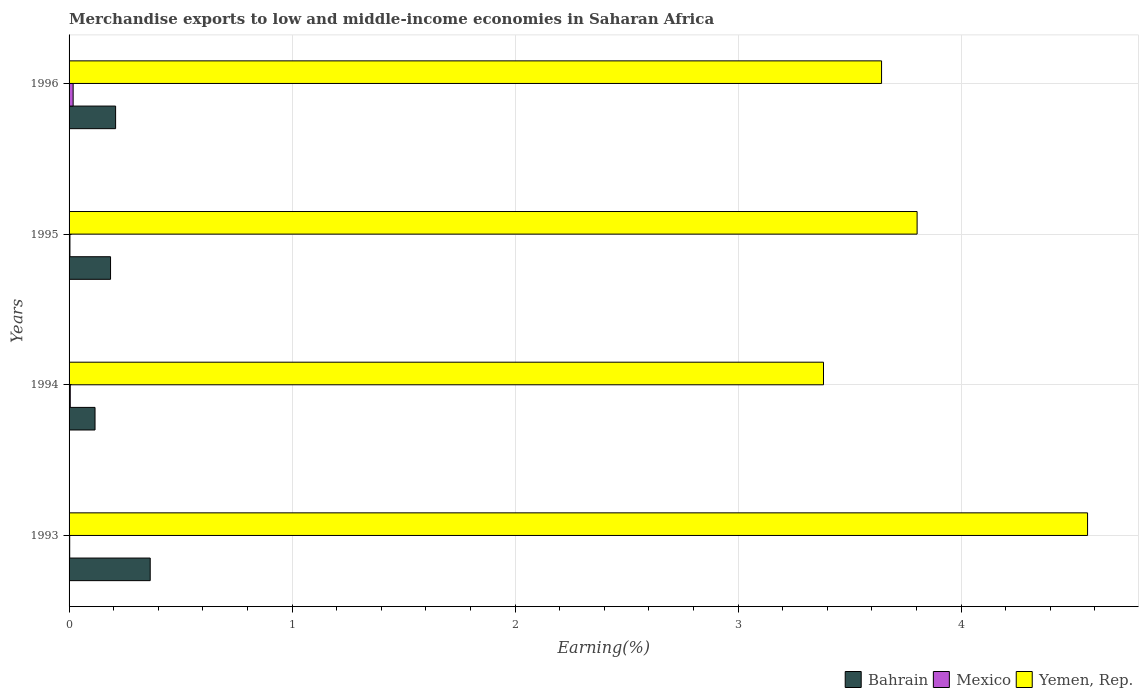How many bars are there on the 2nd tick from the bottom?
Give a very brief answer. 3. What is the label of the 1st group of bars from the top?
Your answer should be compact. 1996. In how many cases, is the number of bars for a given year not equal to the number of legend labels?
Your response must be concise. 0. What is the percentage of amount earned from merchandise exports in Yemen, Rep. in 1996?
Make the answer very short. 3.64. Across all years, what is the maximum percentage of amount earned from merchandise exports in Mexico?
Provide a succinct answer. 0.02. Across all years, what is the minimum percentage of amount earned from merchandise exports in Bahrain?
Give a very brief answer. 0.12. In which year was the percentage of amount earned from merchandise exports in Bahrain minimum?
Provide a short and direct response. 1994. What is the total percentage of amount earned from merchandise exports in Yemen, Rep. in the graph?
Your response must be concise. 15.4. What is the difference between the percentage of amount earned from merchandise exports in Mexico in 1993 and that in 1996?
Offer a terse response. -0.02. What is the difference between the percentage of amount earned from merchandise exports in Mexico in 1994 and the percentage of amount earned from merchandise exports in Yemen, Rep. in 1995?
Your response must be concise. -3.8. What is the average percentage of amount earned from merchandise exports in Yemen, Rep. per year?
Offer a terse response. 3.85. In the year 1995, what is the difference between the percentage of amount earned from merchandise exports in Bahrain and percentage of amount earned from merchandise exports in Yemen, Rep.?
Keep it short and to the point. -3.62. In how many years, is the percentage of amount earned from merchandise exports in Bahrain greater than 3.4 %?
Keep it short and to the point. 0. What is the ratio of the percentage of amount earned from merchandise exports in Bahrain in 1994 to that in 1996?
Keep it short and to the point. 0.56. Is the difference between the percentage of amount earned from merchandise exports in Bahrain in 1995 and 1996 greater than the difference between the percentage of amount earned from merchandise exports in Yemen, Rep. in 1995 and 1996?
Your response must be concise. No. What is the difference between the highest and the second highest percentage of amount earned from merchandise exports in Bahrain?
Give a very brief answer. 0.16. What is the difference between the highest and the lowest percentage of amount earned from merchandise exports in Mexico?
Offer a terse response. 0.02. Is the sum of the percentage of amount earned from merchandise exports in Yemen, Rep. in 1994 and 1995 greater than the maximum percentage of amount earned from merchandise exports in Bahrain across all years?
Provide a succinct answer. Yes. Are the values on the major ticks of X-axis written in scientific E-notation?
Provide a succinct answer. No. Does the graph contain grids?
Keep it short and to the point. Yes. What is the title of the graph?
Give a very brief answer. Merchandise exports to low and middle-income economies in Saharan Africa. Does "Bulgaria" appear as one of the legend labels in the graph?
Keep it short and to the point. No. What is the label or title of the X-axis?
Ensure brevity in your answer.  Earning(%). What is the Earning(%) in Bahrain in 1993?
Make the answer very short. 0.36. What is the Earning(%) in Mexico in 1993?
Your answer should be very brief. 0. What is the Earning(%) of Yemen, Rep. in 1993?
Keep it short and to the point. 4.57. What is the Earning(%) of Bahrain in 1994?
Make the answer very short. 0.12. What is the Earning(%) in Mexico in 1994?
Offer a very short reply. 0.01. What is the Earning(%) of Yemen, Rep. in 1994?
Your answer should be compact. 3.38. What is the Earning(%) of Bahrain in 1995?
Offer a terse response. 0.19. What is the Earning(%) of Mexico in 1995?
Make the answer very short. 0. What is the Earning(%) in Yemen, Rep. in 1995?
Your response must be concise. 3.8. What is the Earning(%) of Bahrain in 1996?
Offer a terse response. 0.21. What is the Earning(%) of Mexico in 1996?
Provide a short and direct response. 0.02. What is the Earning(%) of Yemen, Rep. in 1996?
Make the answer very short. 3.64. Across all years, what is the maximum Earning(%) of Bahrain?
Your answer should be compact. 0.36. Across all years, what is the maximum Earning(%) in Mexico?
Ensure brevity in your answer.  0.02. Across all years, what is the maximum Earning(%) in Yemen, Rep.?
Your response must be concise. 4.57. Across all years, what is the minimum Earning(%) in Bahrain?
Offer a very short reply. 0.12. Across all years, what is the minimum Earning(%) of Mexico?
Keep it short and to the point. 0. Across all years, what is the minimum Earning(%) of Yemen, Rep.?
Provide a succinct answer. 3.38. What is the total Earning(%) of Bahrain in the graph?
Provide a short and direct response. 0.87. What is the total Earning(%) in Mexico in the graph?
Ensure brevity in your answer.  0.03. What is the total Earning(%) of Yemen, Rep. in the graph?
Provide a succinct answer. 15.4. What is the difference between the Earning(%) of Bahrain in 1993 and that in 1994?
Offer a very short reply. 0.25. What is the difference between the Earning(%) in Mexico in 1993 and that in 1994?
Provide a short and direct response. -0. What is the difference between the Earning(%) in Yemen, Rep. in 1993 and that in 1994?
Keep it short and to the point. 1.18. What is the difference between the Earning(%) of Bahrain in 1993 and that in 1995?
Your answer should be compact. 0.18. What is the difference between the Earning(%) in Mexico in 1993 and that in 1995?
Make the answer very short. -0. What is the difference between the Earning(%) in Yemen, Rep. in 1993 and that in 1995?
Your answer should be compact. 0.76. What is the difference between the Earning(%) in Bahrain in 1993 and that in 1996?
Provide a succinct answer. 0.16. What is the difference between the Earning(%) in Mexico in 1993 and that in 1996?
Your response must be concise. -0.02. What is the difference between the Earning(%) in Yemen, Rep. in 1993 and that in 1996?
Give a very brief answer. 0.92. What is the difference between the Earning(%) of Bahrain in 1994 and that in 1995?
Ensure brevity in your answer.  -0.07. What is the difference between the Earning(%) in Mexico in 1994 and that in 1995?
Your response must be concise. 0. What is the difference between the Earning(%) in Yemen, Rep. in 1994 and that in 1995?
Give a very brief answer. -0.42. What is the difference between the Earning(%) in Bahrain in 1994 and that in 1996?
Your answer should be compact. -0.09. What is the difference between the Earning(%) in Mexico in 1994 and that in 1996?
Offer a terse response. -0.01. What is the difference between the Earning(%) in Yemen, Rep. in 1994 and that in 1996?
Keep it short and to the point. -0.26. What is the difference between the Earning(%) in Bahrain in 1995 and that in 1996?
Your response must be concise. -0.02. What is the difference between the Earning(%) in Mexico in 1995 and that in 1996?
Provide a short and direct response. -0.01. What is the difference between the Earning(%) in Yemen, Rep. in 1995 and that in 1996?
Give a very brief answer. 0.16. What is the difference between the Earning(%) in Bahrain in 1993 and the Earning(%) in Mexico in 1994?
Provide a succinct answer. 0.36. What is the difference between the Earning(%) in Bahrain in 1993 and the Earning(%) in Yemen, Rep. in 1994?
Your response must be concise. -3.02. What is the difference between the Earning(%) of Mexico in 1993 and the Earning(%) of Yemen, Rep. in 1994?
Your answer should be compact. -3.38. What is the difference between the Earning(%) in Bahrain in 1993 and the Earning(%) in Mexico in 1995?
Offer a terse response. 0.36. What is the difference between the Earning(%) of Bahrain in 1993 and the Earning(%) of Yemen, Rep. in 1995?
Make the answer very short. -3.44. What is the difference between the Earning(%) in Mexico in 1993 and the Earning(%) in Yemen, Rep. in 1995?
Provide a succinct answer. -3.8. What is the difference between the Earning(%) of Bahrain in 1993 and the Earning(%) of Mexico in 1996?
Offer a terse response. 0.35. What is the difference between the Earning(%) of Bahrain in 1993 and the Earning(%) of Yemen, Rep. in 1996?
Offer a very short reply. -3.28. What is the difference between the Earning(%) in Mexico in 1993 and the Earning(%) in Yemen, Rep. in 1996?
Provide a short and direct response. -3.64. What is the difference between the Earning(%) of Bahrain in 1994 and the Earning(%) of Mexico in 1995?
Provide a succinct answer. 0.11. What is the difference between the Earning(%) of Bahrain in 1994 and the Earning(%) of Yemen, Rep. in 1995?
Make the answer very short. -3.69. What is the difference between the Earning(%) in Mexico in 1994 and the Earning(%) in Yemen, Rep. in 1995?
Give a very brief answer. -3.8. What is the difference between the Earning(%) in Bahrain in 1994 and the Earning(%) in Mexico in 1996?
Provide a succinct answer. 0.1. What is the difference between the Earning(%) of Bahrain in 1994 and the Earning(%) of Yemen, Rep. in 1996?
Give a very brief answer. -3.53. What is the difference between the Earning(%) of Mexico in 1994 and the Earning(%) of Yemen, Rep. in 1996?
Provide a succinct answer. -3.64. What is the difference between the Earning(%) in Bahrain in 1995 and the Earning(%) in Mexico in 1996?
Offer a terse response. 0.17. What is the difference between the Earning(%) in Bahrain in 1995 and the Earning(%) in Yemen, Rep. in 1996?
Offer a very short reply. -3.46. What is the difference between the Earning(%) of Mexico in 1995 and the Earning(%) of Yemen, Rep. in 1996?
Provide a short and direct response. -3.64. What is the average Earning(%) in Bahrain per year?
Ensure brevity in your answer.  0.22. What is the average Earning(%) in Mexico per year?
Ensure brevity in your answer.  0.01. What is the average Earning(%) of Yemen, Rep. per year?
Provide a succinct answer. 3.85. In the year 1993, what is the difference between the Earning(%) of Bahrain and Earning(%) of Mexico?
Offer a terse response. 0.36. In the year 1993, what is the difference between the Earning(%) of Bahrain and Earning(%) of Yemen, Rep.?
Keep it short and to the point. -4.2. In the year 1993, what is the difference between the Earning(%) of Mexico and Earning(%) of Yemen, Rep.?
Your answer should be very brief. -4.56. In the year 1994, what is the difference between the Earning(%) in Bahrain and Earning(%) in Mexico?
Your answer should be very brief. 0.11. In the year 1994, what is the difference between the Earning(%) in Bahrain and Earning(%) in Yemen, Rep.?
Ensure brevity in your answer.  -3.27. In the year 1994, what is the difference between the Earning(%) in Mexico and Earning(%) in Yemen, Rep.?
Give a very brief answer. -3.38. In the year 1995, what is the difference between the Earning(%) of Bahrain and Earning(%) of Mexico?
Your answer should be compact. 0.18. In the year 1995, what is the difference between the Earning(%) in Bahrain and Earning(%) in Yemen, Rep.?
Offer a very short reply. -3.62. In the year 1995, what is the difference between the Earning(%) in Mexico and Earning(%) in Yemen, Rep.?
Provide a short and direct response. -3.8. In the year 1996, what is the difference between the Earning(%) in Bahrain and Earning(%) in Mexico?
Provide a succinct answer. 0.19. In the year 1996, what is the difference between the Earning(%) of Bahrain and Earning(%) of Yemen, Rep.?
Your answer should be very brief. -3.43. In the year 1996, what is the difference between the Earning(%) in Mexico and Earning(%) in Yemen, Rep.?
Your answer should be very brief. -3.62. What is the ratio of the Earning(%) in Bahrain in 1993 to that in 1994?
Give a very brief answer. 3.13. What is the ratio of the Earning(%) in Mexico in 1993 to that in 1994?
Make the answer very short. 0.52. What is the ratio of the Earning(%) of Yemen, Rep. in 1993 to that in 1994?
Your answer should be very brief. 1.35. What is the ratio of the Earning(%) in Bahrain in 1993 to that in 1995?
Keep it short and to the point. 1.96. What is the ratio of the Earning(%) of Mexico in 1993 to that in 1995?
Your answer should be very brief. 0.72. What is the ratio of the Earning(%) in Yemen, Rep. in 1993 to that in 1995?
Provide a succinct answer. 1.2. What is the ratio of the Earning(%) in Bahrain in 1993 to that in 1996?
Offer a terse response. 1.74. What is the ratio of the Earning(%) of Mexico in 1993 to that in 1996?
Your answer should be compact. 0.15. What is the ratio of the Earning(%) of Yemen, Rep. in 1993 to that in 1996?
Offer a terse response. 1.25. What is the ratio of the Earning(%) in Bahrain in 1994 to that in 1995?
Offer a terse response. 0.63. What is the ratio of the Earning(%) of Mexico in 1994 to that in 1995?
Provide a succinct answer. 1.39. What is the ratio of the Earning(%) in Yemen, Rep. in 1994 to that in 1995?
Give a very brief answer. 0.89. What is the ratio of the Earning(%) in Bahrain in 1994 to that in 1996?
Offer a very short reply. 0.56. What is the ratio of the Earning(%) of Mexico in 1994 to that in 1996?
Your answer should be compact. 0.29. What is the ratio of the Earning(%) in Yemen, Rep. in 1994 to that in 1996?
Provide a short and direct response. 0.93. What is the ratio of the Earning(%) in Bahrain in 1995 to that in 1996?
Provide a short and direct response. 0.89. What is the ratio of the Earning(%) in Mexico in 1995 to that in 1996?
Give a very brief answer. 0.21. What is the ratio of the Earning(%) in Yemen, Rep. in 1995 to that in 1996?
Provide a short and direct response. 1.04. What is the difference between the highest and the second highest Earning(%) of Bahrain?
Offer a terse response. 0.16. What is the difference between the highest and the second highest Earning(%) in Mexico?
Your response must be concise. 0.01. What is the difference between the highest and the second highest Earning(%) of Yemen, Rep.?
Your response must be concise. 0.76. What is the difference between the highest and the lowest Earning(%) of Bahrain?
Offer a very short reply. 0.25. What is the difference between the highest and the lowest Earning(%) of Mexico?
Make the answer very short. 0.02. What is the difference between the highest and the lowest Earning(%) in Yemen, Rep.?
Your answer should be compact. 1.18. 